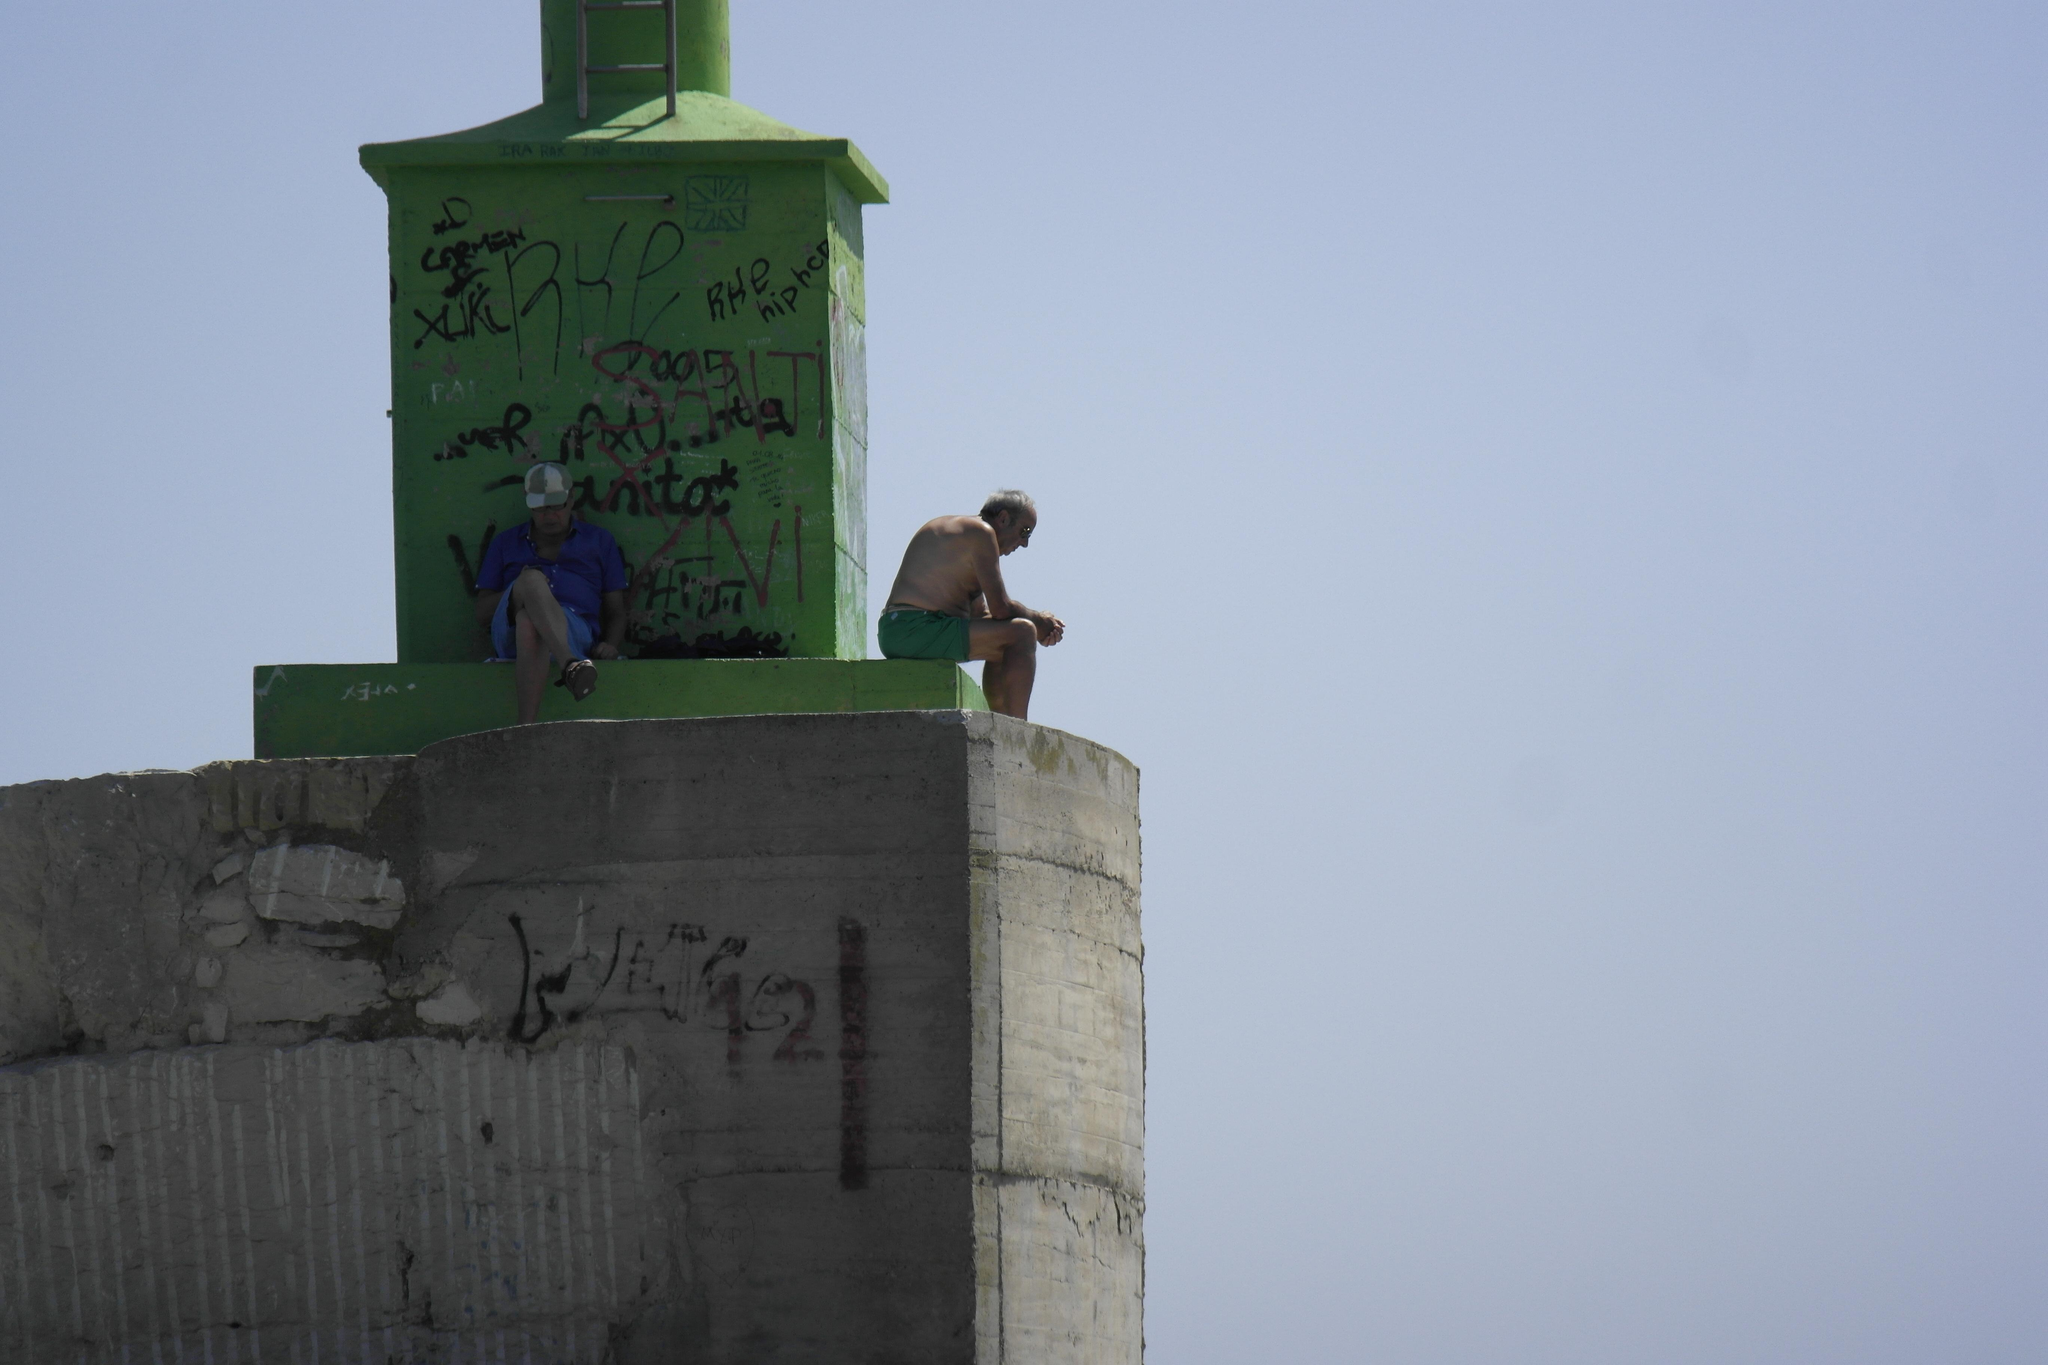Who or what can be seen in the image? There are people in the image. What are the people doing or standing on? The people are on some form of architecture. What can be seen in the distance or background of the image? The sky is visible in the background of the image. What type of fold can be seen in the image? There is no fold present in the image. What kind of noise is being made by the people in the image? The image does not provide any information about noise or sounds being made by the people. 